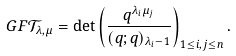Convert formula to latex. <formula><loc_0><loc_0><loc_500><loc_500>\ G F { \mathcal { T } _ { \lambda , \mu } } = \det \left ( \frac { q ^ { \lambda _ { i } \mu _ { j } } } { ( q ; q ) _ { \lambda _ { i } - 1 } } \right ) _ { 1 \leq i , j \leq n } .</formula> 